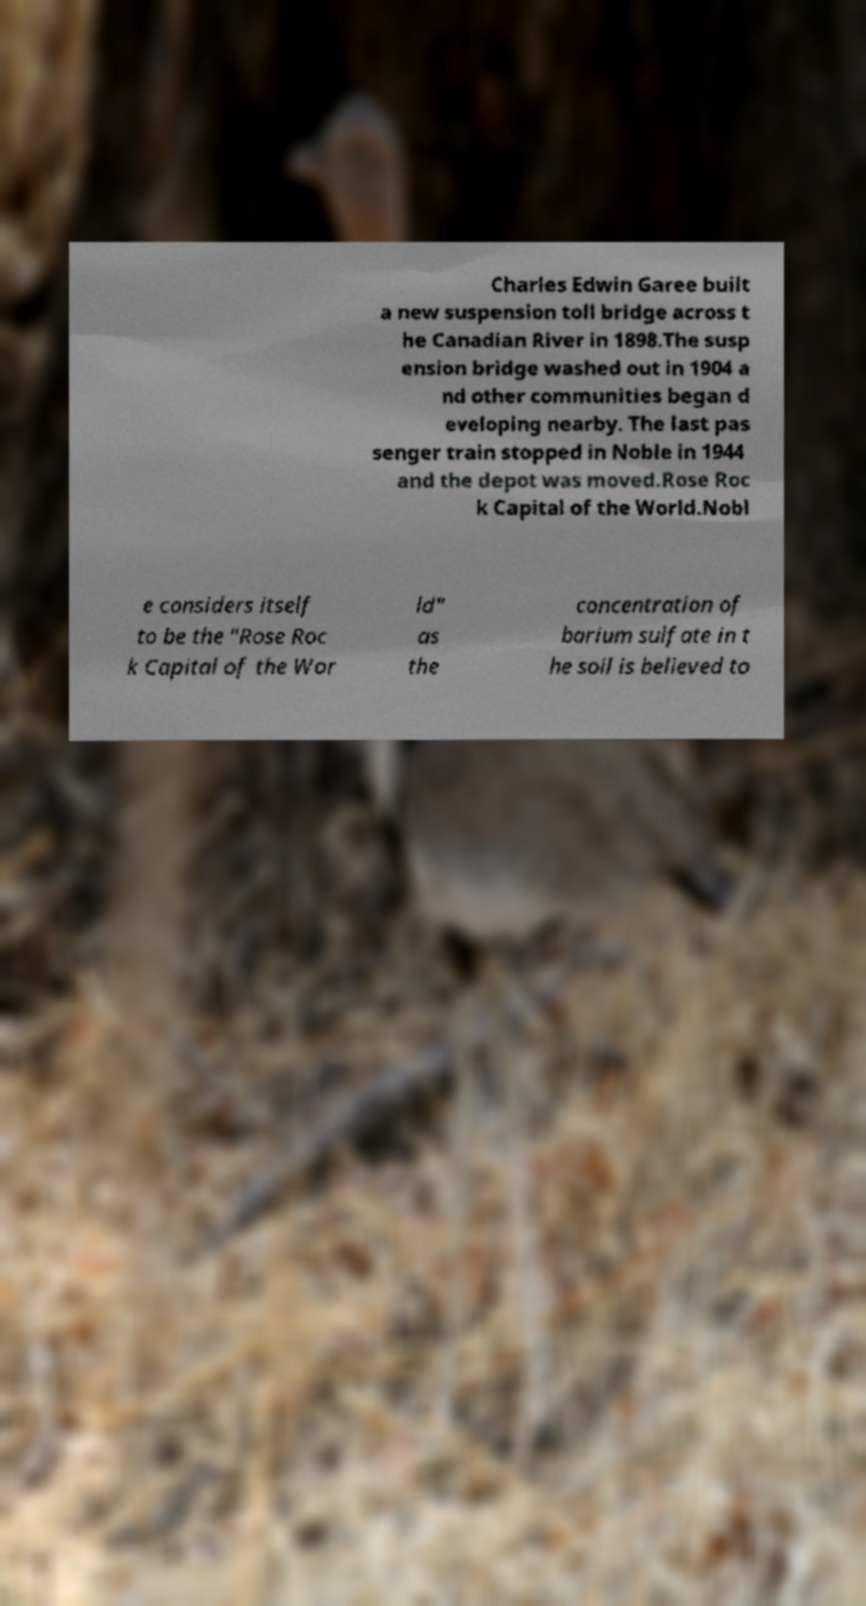Please identify and transcribe the text found in this image. Charles Edwin Garee built a new suspension toll bridge across t he Canadian River in 1898.The susp ension bridge washed out in 1904 a nd other communities began d eveloping nearby. The last pas senger train stopped in Noble in 1944 and the depot was moved.Rose Roc k Capital of the World.Nobl e considers itself to be the "Rose Roc k Capital of the Wor ld" as the concentration of barium sulfate in t he soil is believed to 